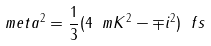Convert formula to latex. <formula><loc_0><loc_0><loc_500><loc_500>\ m e t a ^ { 2 } = \frac { 1 } { 3 } ( 4 \ m K ^ { 2 } - \mp i ^ { 2 } ) \ f s</formula> 